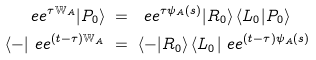<formula> <loc_0><loc_0><loc_500><loc_500>\ e e ^ { \tau \mathbb { W } _ { A } } | P _ { 0 } \rangle & \ = \ \ e e ^ { \tau \psi _ { A } ( s ) } | R _ { 0 } \rangle \, \langle L _ { 0 } | P _ { 0 } \rangle \\ \langle - | \ e e ^ { ( t - \tau ) \mathbb { W } _ { A } } & \ = \ \langle - | R _ { 0 } \rangle \, \langle L _ { 0 } | \ e e ^ { ( t - \tau ) \psi _ { A } ( s ) }</formula> 